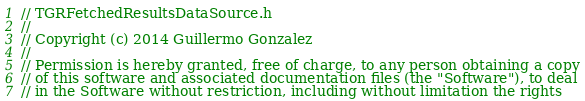<code> <loc_0><loc_0><loc_500><loc_500><_C_>// TGRFetchedResultsDataSource.h
// 
// Copyright (c) 2014 Guillermo Gonzalez
//
// Permission is hereby granted, free of charge, to any person obtaining a copy
// of this software and associated documentation files (the "Software"), to deal
// in the Software without restriction, including without limitation the rights</code> 